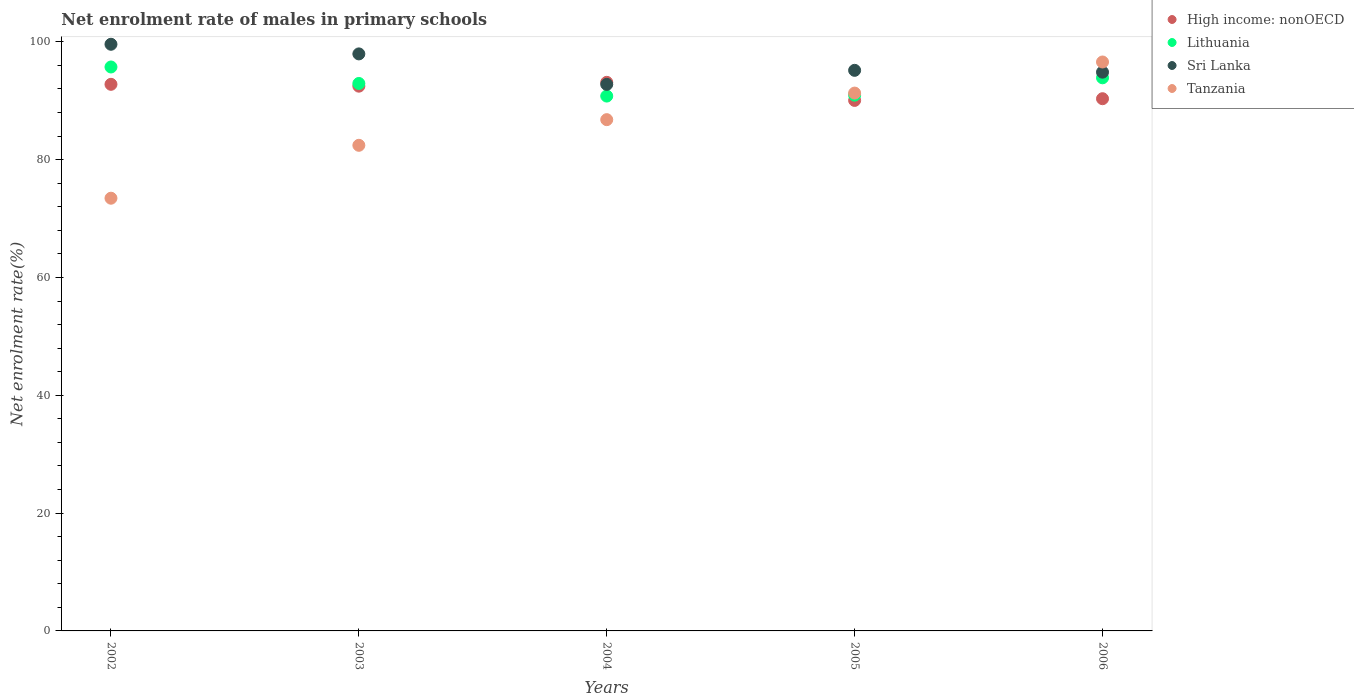How many different coloured dotlines are there?
Give a very brief answer. 4. Is the number of dotlines equal to the number of legend labels?
Provide a succinct answer. Yes. What is the net enrolment rate of males in primary schools in Lithuania in 2005?
Keep it short and to the point. 90.94. Across all years, what is the maximum net enrolment rate of males in primary schools in Lithuania?
Make the answer very short. 95.73. Across all years, what is the minimum net enrolment rate of males in primary schools in Lithuania?
Ensure brevity in your answer.  90.79. In which year was the net enrolment rate of males in primary schools in Sri Lanka minimum?
Offer a terse response. 2004. What is the total net enrolment rate of males in primary schools in High income: nonOECD in the graph?
Your answer should be very brief. 458.77. What is the difference between the net enrolment rate of males in primary schools in Sri Lanka in 2002 and that in 2003?
Provide a succinct answer. 1.63. What is the difference between the net enrolment rate of males in primary schools in Sri Lanka in 2006 and the net enrolment rate of males in primary schools in Lithuania in 2002?
Your answer should be very brief. -0.88. What is the average net enrolment rate of males in primary schools in Sri Lanka per year?
Your response must be concise. 96.06. In the year 2003, what is the difference between the net enrolment rate of males in primary schools in High income: nonOECD and net enrolment rate of males in primary schools in Sri Lanka?
Make the answer very short. -5.48. In how many years, is the net enrolment rate of males in primary schools in Sri Lanka greater than 12 %?
Provide a succinct answer. 5. What is the ratio of the net enrolment rate of males in primary schools in Tanzania in 2003 to that in 2004?
Keep it short and to the point. 0.95. What is the difference between the highest and the second highest net enrolment rate of males in primary schools in Sri Lanka?
Your response must be concise. 1.63. What is the difference between the highest and the lowest net enrolment rate of males in primary schools in Lithuania?
Keep it short and to the point. 4.94. Is the sum of the net enrolment rate of males in primary schools in High income: nonOECD in 2002 and 2003 greater than the maximum net enrolment rate of males in primary schools in Tanzania across all years?
Your response must be concise. Yes. Is it the case that in every year, the sum of the net enrolment rate of males in primary schools in High income: nonOECD and net enrolment rate of males in primary schools in Sri Lanka  is greater than the net enrolment rate of males in primary schools in Tanzania?
Provide a short and direct response. Yes. Is the net enrolment rate of males in primary schools in Sri Lanka strictly greater than the net enrolment rate of males in primary schools in Lithuania over the years?
Your answer should be compact. Yes. How many dotlines are there?
Provide a short and direct response. 4. What is the difference between two consecutive major ticks on the Y-axis?
Give a very brief answer. 20. Are the values on the major ticks of Y-axis written in scientific E-notation?
Offer a terse response. No. Where does the legend appear in the graph?
Your response must be concise. Top right. How many legend labels are there?
Make the answer very short. 4. How are the legend labels stacked?
Give a very brief answer. Vertical. What is the title of the graph?
Keep it short and to the point. Net enrolment rate of males in primary schools. What is the label or title of the Y-axis?
Provide a succinct answer. Net enrolment rate(%). What is the Net enrolment rate(%) of High income: nonOECD in 2002?
Give a very brief answer. 92.78. What is the Net enrolment rate(%) of Lithuania in 2002?
Your answer should be very brief. 95.73. What is the Net enrolment rate(%) of Sri Lanka in 2002?
Keep it short and to the point. 99.58. What is the Net enrolment rate(%) in Tanzania in 2002?
Ensure brevity in your answer.  73.45. What is the Net enrolment rate(%) of High income: nonOECD in 2003?
Keep it short and to the point. 92.47. What is the Net enrolment rate(%) of Lithuania in 2003?
Give a very brief answer. 92.93. What is the Net enrolment rate(%) in Sri Lanka in 2003?
Your answer should be very brief. 97.95. What is the Net enrolment rate(%) of Tanzania in 2003?
Provide a succinct answer. 82.43. What is the Net enrolment rate(%) of High income: nonOECD in 2004?
Make the answer very short. 93.12. What is the Net enrolment rate(%) of Lithuania in 2004?
Ensure brevity in your answer.  90.79. What is the Net enrolment rate(%) of Sri Lanka in 2004?
Ensure brevity in your answer.  92.78. What is the Net enrolment rate(%) in Tanzania in 2004?
Your answer should be compact. 86.79. What is the Net enrolment rate(%) in High income: nonOECD in 2005?
Ensure brevity in your answer.  90.05. What is the Net enrolment rate(%) of Lithuania in 2005?
Make the answer very short. 90.94. What is the Net enrolment rate(%) in Sri Lanka in 2005?
Offer a very short reply. 95.16. What is the Net enrolment rate(%) of Tanzania in 2005?
Your answer should be compact. 91.3. What is the Net enrolment rate(%) in High income: nonOECD in 2006?
Your answer should be compact. 90.34. What is the Net enrolment rate(%) of Lithuania in 2006?
Ensure brevity in your answer.  93.89. What is the Net enrolment rate(%) in Sri Lanka in 2006?
Make the answer very short. 94.85. What is the Net enrolment rate(%) in Tanzania in 2006?
Ensure brevity in your answer.  96.57. Across all years, what is the maximum Net enrolment rate(%) of High income: nonOECD?
Your response must be concise. 93.12. Across all years, what is the maximum Net enrolment rate(%) in Lithuania?
Your answer should be compact. 95.73. Across all years, what is the maximum Net enrolment rate(%) of Sri Lanka?
Provide a short and direct response. 99.58. Across all years, what is the maximum Net enrolment rate(%) of Tanzania?
Your answer should be compact. 96.57. Across all years, what is the minimum Net enrolment rate(%) of High income: nonOECD?
Your answer should be compact. 90.05. Across all years, what is the minimum Net enrolment rate(%) in Lithuania?
Your answer should be very brief. 90.79. Across all years, what is the minimum Net enrolment rate(%) of Sri Lanka?
Ensure brevity in your answer.  92.78. Across all years, what is the minimum Net enrolment rate(%) of Tanzania?
Give a very brief answer. 73.45. What is the total Net enrolment rate(%) in High income: nonOECD in the graph?
Make the answer very short. 458.77. What is the total Net enrolment rate(%) in Lithuania in the graph?
Ensure brevity in your answer.  464.28. What is the total Net enrolment rate(%) of Sri Lanka in the graph?
Ensure brevity in your answer.  480.31. What is the total Net enrolment rate(%) in Tanzania in the graph?
Provide a succinct answer. 430.55. What is the difference between the Net enrolment rate(%) of High income: nonOECD in 2002 and that in 2003?
Give a very brief answer. 0.31. What is the difference between the Net enrolment rate(%) of Lithuania in 2002 and that in 2003?
Your answer should be compact. 2.8. What is the difference between the Net enrolment rate(%) in Sri Lanka in 2002 and that in 2003?
Make the answer very short. 1.63. What is the difference between the Net enrolment rate(%) in Tanzania in 2002 and that in 2003?
Provide a short and direct response. -8.98. What is the difference between the Net enrolment rate(%) of High income: nonOECD in 2002 and that in 2004?
Your answer should be very brief. -0.34. What is the difference between the Net enrolment rate(%) of Lithuania in 2002 and that in 2004?
Provide a succinct answer. 4.94. What is the difference between the Net enrolment rate(%) in Sri Lanka in 2002 and that in 2004?
Provide a succinct answer. 6.81. What is the difference between the Net enrolment rate(%) in Tanzania in 2002 and that in 2004?
Make the answer very short. -13.33. What is the difference between the Net enrolment rate(%) of High income: nonOECD in 2002 and that in 2005?
Offer a very short reply. 2.73. What is the difference between the Net enrolment rate(%) of Lithuania in 2002 and that in 2005?
Your answer should be compact. 4.78. What is the difference between the Net enrolment rate(%) of Sri Lanka in 2002 and that in 2005?
Provide a succinct answer. 4.43. What is the difference between the Net enrolment rate(%) in Tanzania in 2002 and that in 2005?
Ensure brevity in your answer.  -17.85. What is the difference between the Net enrolment rate(%) of High income: nonOECD in 2002 and that in 2006?
Your answer should be very brief. 2.44. What is the difference between the Net enrolment rate(%) of Lithuania in 2002 and that in 2006?
Provide a succinct answer. 1.84. What is the difference between the Net enrolment rate(%) in Sri Lanka in 2002 and that in 2006?
Keep it short and to the point. 4.74. What is the difference between the Net enrolment rate(%) in Tanzania in 2002 and that in 2006?
Provide a short and direct response. -23.12. What is the difference between the Net enrolment rate(%) in High income: nonOECD in 2003 and that in 2004?
Offer a terse response. -0.65. What is the difference between the Net enrolment rate(%) of Lithuania in 2003 and that in 2004?
Offer a very short reply. 2.14. What is the difference between the Net enrolment rate(%) in Sri Lanka in 2003 and that in 2004?
Offer a very short reply. 5.17. What is the difference between the Net enrolment rate(%) in Tanzania in 2003 and that in 2004?
Keep it short and to the point. -4.35. What is the difference between the Net enrolment rate(%) of High income: nonOECD in 2003 and that in 2005?
Your answer should be very brief. 2.42. What is the difference between the Net enrolment rate(%) of Lithuania in 2003 and that in 2005?
Offer a very short reply. 1.99. What is the difference between the Net enrolment rate(%) of Sri Lanka in 2003 and that in 2005?
Offer a terse response. 2.79. What is the difference between the Net enrolment rate(%) in Tanzania in 2003 and that in 2005?
Give a very brief answer. -8.87. What is the difference between the Net enrolment rate(%) of High income: nonOECD in 2003 and that in 2006?
Offer a terse response. 2.13. What is the difference between the Net enrolment rate(%) in Lithuania in 2003 and that in 2006?
Give a very brief answer. -0.96. What is the difference between the Net enrolment rate(%) in Sri Lanka in 2003 and that in 2006?
Your answer should be compact. 3.1. What is the difference between the Net enrolment rate(%) of Tanzania in 2003 and that in 2006?
Provide a succinct answer. -14.14. What is the difference between the Net enrolment rate(%) of High income: nonOECD in 2004 and that in 2005?
Your answer should be compact. 3.07. What is the difference between the Net enrolment rate(%) of Lithuania in 2004 and that in 2005?
Offer a terse response. -0.15. What is the difference between the Net enrolment rate(%) of Sri Lanka in 2004 and that in 2005?
Give a very brief answer. -2.38. What is the difference between the Net enrolment rate(%) in Tanzania in 2004 and that in 2005?
Your answer should be very brief. -4.51. What is the difference between the Net enrolment rate(%) in High income: nonOECD in 2004 and that in 2006?
Provide a short and direct response. 2.78. What is the difference between the Net enrolment rate(%) of Lithuania in 2004 and that in 2006?
Provide a succinct answer. -3.1. What is the difference between the Net enrolment rate(%) of Sri Lanka in 2004 and that in 2006?
Your response must be concise. -2.07. What is the difference between the Net enrolment rate(%) in Tanzania in 2004 and that in 2006?
Provide a succinct answer. -9.79. What is the difference between the Net enrolment rate(%) of High income: nonOECD in 2005 and that in 2006?
Your answer should be compact. -0.29. What is the difference between the Net enrolment rate(%) of Lithuania in 2005 and that in 2006?
Make the answer very short. -2.95. What is the difference between the Net enrolment rate(%) of Sri Lanka in 2005 and that in 2006?
Ensure brevity in your answer.  0.31. What is the difference between the Net enrolment rate(%) of Tanzania in 2005 and that in 2006?
Your answer should be very brief. -5.28. What is the difference between the Net enrolment rate(%) of High income: nonOECD in 2002 and the Net enrolment rate(%) of Lithuania in 2003?
Your answer should be very brief. -0.15. What is the difference between the Net enrolment rate(%) of High income: nonOECD in 2002 and the Net enrolment rate(%) of Sri Lanka in 2003?
Offer a terse response. -5.16. What is the difference between the Net enrolment rate(%) in High income: nonOECD in 2002 and the Net enrolment rate(%) in Tanzania in 2003?
Offer a terse response. 10.35. What is the difference between the Net enrolment rate(%) of Lithuania in 2002 and the Net enrolment rate(%) of Sri Lanka in 2003?
Make the answer very short. -2.22. What is the difference between the Net enrolment rate(%) of Lithuania in 2002 and the Net enrolment rate(%) of Tanzania in 2003?
Your response must be concise. 13.3. What is the difference between the Net enrolment rate(%) in Sri Lanka in 2002 and the Net enrolment rate(%) in Tanzania in 2003?
Your answer should be compact. 17.15. What is the difference between the Net enrolment rate(%) in High income: nonOECD in 2002 and the Net enrolment rate(%) in Lithuania in 2004?
Provide a succinct answer. 1.99. What is the difference between the Net enrolment rate(%) of High income: nonOECD in 2002 and the Net enrolment rate(%) of Sri Lanka in 2004?
Provide a succinct answer. 0.01. What is the difference between the Net enrolment rate(%) in High income: nonOECD in 2002 and the Net enrolment rate(%) in Tanzania in 2004?
Give a very brief answer. 6. What is the difference between the Net enrolment rate(%) of Lithuania in 2002 and the Net enrolment rate(%) of Sri Lanka in 2004?
Offer a terse response. 2.95. What is the difference between the Net enrolment rate(%) in Lithuania in 2002 and the Net enrolment rate(%) in Tanzania in 2004?
Provide a succinct answer. 8.94. What is the difference between the Net enrolment rate(%) of Sri Lanka in 2002 and the Net enrolment rate(%) of Tanzania in 2004?
Your response must be concise. 12.8. What is the difference between the Net enrolment rate(%) of High income: nonOECD in 2002 and the Net enrolment rate(%) of Lithuania in 2005?
Provide a short and direct response. 1.84. What is the difference between the Net enrolment rate(%) in High income: nonOECD in 2002 and the Net enrolment rate(%) in Sri Lanka in 2005?
Keep it short and to the point. -2.37. What is the difference between the Net enrolment rate(%) of High income: nonOECD in 2002 and the Net enrolment rate(%) of Tanzania in 2005?
Give a very brief answer. 1.49. What is the difference between the Net enrolment rate(%) in Lithuania in 2002 and the Net enrolment rate(%) in Sri Lanka in 2005?
Your answer should be compact. 0.57. What is the difference between the Net enrolment rate(%) in Lithuania in 2002 and the Net enrolment rate(%) in Tanzania in 2005?
Offer a terse response. 4.43. What is the difference between the Net enrolment rate(%) of Sri Lanka in 2002 and the Net enrolment rate(%) of Tanzania in 2005?
Your response must be concise. 8.29. What is the difference between the Net enrolment rate(%) of High income: nonOECD in 2002 and the Net enrolment rate(%) of Lithuania in 2006?
Give a very brief answer. -1.11. What is the difference between the Net enrolment rate(%) in High income: nonOECD in 2002 and the Net enrolment rate(%) in Sri Lanka in 2006?
Make the answer very short. -2.06. What is the difference between the Net enrolment rate(%) of High income: nonOECD in 2002 and the Net enrolment rate(%) of Tanzania in 2006?
Provide a succinct answer. -3.79. What is the difference between the Net enrolment rate(%) of Lithuania in 2002 and the Net enrolment rate(%) of Sri Lanka in 2006?
Keep it short and to the point. 0.88. What is the difference between the Net enrolment rate(%) of Lithuania in 2002 and the Net enrolment rate(%) of Tanzania in 2006?
Your answer should be very brief. -0.85. What is the difference between the Net enrolment rate(%) of Sri Lanka in 2002 and the Net enrolment rate(%) of Tanzania in 2006?
Offer a very short reply. 3.01. What is the difference between the Net enrolment rate(%) of High income: nonOECD in 2003 and the Net enrolment rate(%) of Lithuania in 2004?
Provide a short and direct response. 1.68. What is the difference between the Net enrolment rate(%) of High income: nonOECD in 2003 and the Net enrolment rate(%) of Sri Lanka in 2004?
Keep it short and to the point. -0.3. What is the difference between the Net enrolment rate(%) in High income: nonOECD in 2003 and the Net enrolment rate(%) in Tanzania in 2004?
Provide a short and direct response. 5.68. What is the difference between the Net enrolment rate(%) of Lithuania in 2003 and the Net enrolment rate(%) of Sri Lanka in 2004?
Offer a terse response. 0.15. What is the difference between the Net enrolment rate(%) of Lithuania in 2003 and the Net enrolment rate(%) of Tanzania in 2004?
Provide a short and direct response. 6.14. What is the difference between the Net enrolment rate(%) of Sri Lanka in 2003 and the Net enrolment rate(%) of Tanzania in 2004?
Provide a succinct answer. 11.16. What is the difference between the Net enrolment rate(%) in High income: nonOECD in 2003 and the Net enrolment rate(%) in Lithuania in 2005?
Offer a terse response. 1.53. What is the difference between the Net enrolment rate(%) in High income: nonOECD in 2003 and the Net enrolment rate(%) in Sri Lanka in 2005?
Your answer should be very brief. -2.69. What is the difference between the Net enrolment rate(%) in High income: nonOECD in 2003 and the Net enrolment rate(%) in Tanzania in 2005?
Provide a short and direct response. 1.17. What is the difference between the Net enrolment rate(%) of Lithuania in 2003 and the Net enrolment rate(%) of Sri Lanka in 2005?
Keep it short and to the point. -2.23. What is the difference between the Net enrolment rate(%) in Lithuania in 2003 and the Net enrolment rate(%) in Tanzania in 2005?
Offer a very short reply. 1.63. What is the difference between the Net enrolment rate(%) in Sri Lanka in 2003 and the Net enrolment rate(%) in Tanzania in 2005?
Provide a succinct answer. 6.65. What is the difference between the Net enrolment rate(%) in High income: nonOECD in 2003 and the Net enrolment rate(%) in Lithuania in 2006?
Keep it short and to the point. -1.42. What is the difference between the Net enrolment rate(%) of High income: nonOECD in 2003 and the Net enrolment rate(%) of Sri Lanka in 2006?
Keep it short and to the point. -2.38. What is the difference between the Net enrolment rate(%) of High income: nonOECD in 2003 and the Net enrolment rate(%) of Tanzania in 2006?
Your response must be concise. -4.1. What is the difference between the Net enrolment rate(%) in Lithuania in 2003 and the Net enrolment rate(%) in Sri Lanka in 2006?
Your answer should be compact. -1.92. What is the difference between the Net enrolment rate(%) of Lithuania in 2003 and the Net enrolment rate(%) of Tanzania in 2006?
Give a very brief answer. -3.64. What is the difference between the Net enrolment rate(%) in Sri Lanka in 2003 and the Net enrolment rate(%) in Tanzania in 2006?
Provide a short and direct response. 1.37. What is the difference between the Net enrolment rate(%) of High income: nonOECD in 2004 and the Net enrolment rate(%) of Lithuania in 2005?
Offer a terse response. 2.18. What is the difference between the Net enrolment rate(%) in High income: nonOECD in 2004 and the Net enrolment rate(%) in Sri Lanka in 2005?
Provide a short and direct response. -2.04. What is the difference between the Net enrolment rate(%) of High income: nonOECD in 2004 and the Net enrolment rate(%) of Tanzania in 2005?
Provide a succinct answer. 1.82. What is the difference between the Net enrolment rate(%) of Lithuania in 2004 and the Net enrolment rate(%) of Sri Lanka in 2005?
Ensure brevity in your answer.  -4.37. What is the difference between the Net enrolment rate(%) of Lithuania in 2004 and the Net enrolment rate(%) of Tanzania in 2005?
Ensure brevity in your answer.  -0.51. What is the difference between the Net enrolment rate(%) of Sri Lanka in 2004 and the Net enrolment rate(%) of Tanzania in 2005?
Keep it short and to the point. 1.48. What is the difference between the Net enrolment rate(%) in High income: nonOECD in 2004 and the Net enrolment rate(%) in Lithuania in 2006?
Offer a terse response. -0.77. What is the difference between the Net enrolment rate(%) of High income: nonOECD in 2004 and the Net enrolment rate(%) of Sri Lanka in 2006?
Offer a very short reply. -1.72. What is the difference between the Net enrolment rate(%) of High income: nonOECD in 2004 and the Net enrolment rate(%) of Tanzania in 2006?
Your response must be concise. -3.45. What is the difference between the Net enrolment rate(%) of Lithuania in 2004 and the Net enrolment rate(%) of Sri Lanka in 2006?
Your answer should be compact. -4.06. What is the difference between the Net enrolment rate(%) in Lithuania in 2004 and the Net enrolment rate(%) in Tanzania in 2006?
Keep it short and to the point. -5.78. What is the difference between the Net enrolment rate(%) of Sri Lanka in 2004 and the Net enrolment rate(%) of Tanzania in 2006?
Make the answer very short. -3.8. What is the difference between the Net enrolment rate(%) in High income: nonOECD in 2005 and the Net enrolment rate(%) in Lithuania in 2006?
Offer a very short reply. -3.84. What is the difference between the Net enrolment rate(%) of High income: nonOECD in 2005 and the Net enrolment rate(%) of Sri Lanka in 2006?
Your answer should be compact. -4.8. What is the difference between the Net enrolment rate(%) in High income: nonOECD in 2005 and the Net enrolment rate(%) in Tanzania in 2006?
Your answer should be very brief. -6.52. What is the difference between the Net enrolment rate(%) in Lithuania in 2005 and the Net enrolment rate(%) in Sri Lanka in 2006?
Your answer should be very brief. -3.9. What is the difference between the Net enrolment rate(%) of Lithuania in 2005 and the Net enrolment rate(%) of Tanzania in 2006?
Provide a short and direct response. -5.63. What is the difference between the Net enrolment rate(%) of Sri Lanka in 2005 and the Net enrolment rate(%) of Tanzania in 2006?
Give a very brief answer. -1.42. What is the average Net enrolment rate(%) of High income: nonOECD per year?
Your answer should be very brief. 91.75. What is the average Net enrolment rate(%) of Lithuania per year?
Offer a terse response. 92.86. What is the average Net enrolment rate(%) of Sri Lanka per year?
Keep it short and to the point. 96.06. What is the average Net enrolment rate(%) of Tanzania per year?
Make the answer very short. 86.11. In the year 2002, what is the difference between the Net enrolment rate(%) in High income: nonOECD and Net enrolment rate(%) in Lithuania?
Give a very brief answer. -2.94. In the year 2002, what is the difference between the Net enrolment rate(%) in High income: nonOECD and Net enrolment rate(%) in Sri Lanka?
Provide a short and direct response. -6.8. In the year 2002, what is the difference between the Net enrolment rate(%) of High income: nonOECD and Net enrolment rate(%) of Tanzania?
Provide a succinct answer. 19.33. In the year 2002, what is the difference between the Net enrolment rate(%) in Lithuania and Net enrolment rate(%) in Sri Lanka?
Keep it short and to the point. -3.86. In the year 2002, what is the difference between the Net enrolment rate(%) in Lithuania and Net enrolment rate(%) in Tanzania?
Your answer should be very brief. 22.28. In the year 2002, what is the difference between the Net enrolment rate(%) of Sri Lanka and Net enrolment rate(%) of Tanzania?
Your response must be concise. 26.13. In the year 2003, what is the difference between the Net enrolment rate(%) in High income: nonOECD and Net enrolment rate(%) in Lithuania?
Ensure brevity in your answer.  -0.46. In the year 2003, what is the difference between the Net enrolment rate(%) in High income: nonOECD and Net enrolment rate(%) in Sri Lanka?
Make the answer very short. -5.48. In the year 2003, what is the difference between the Net enrolment rate(%) of High income: nonOECD and Net enrolment rate(%) of Tanzania?
Make the answer very short. 10.04. In the year 2003, what is the difference between the Net enrolment rate(%) of Lithuania and Net enrolment rate(%) of Sri Lanka?
Give a very brief answer. -5.02. In the year 2003, what is the difference between the Net enrolment rate(%) of Lithuania and Net enrolment rate(%) of Tanzania?
Your answer should be compact. 10.5. In the year 2003, what is the difference between the Net enrolment rate(%) in Sri Lanka and Net enrolment rate(%) in Tanzania?
Ensure brevity in your answer.  15.52. In the year 2004, what is the difference between the Net enrolment rate(%) in High income: nonOECD and Net enrolment rate(%) in Lithuania?
Offer a very short reply. 2.33. In the year 2004, what is the difference between the Net enrolment rate(%) in High income: nonOECD and Net enrolment rate(%) in Sri Lanka?
Provide a short and direct response. 0.35. In the year 2004, what is the difference between the Net enrolment rate(%) of High income: nonOECD and Net enrolment rate(%) of Tanzania?
Your answer should be very brief. 6.34. In the year 2004, what is the difference between the Net enrolment rate(%) of Lithuania and Net enrolment rate(%) of Sri Lanka?
Provide a succinct answer. -1.98. In the year 2004, what is the difference between the Net enrolment rate(%) in Lithuania and Net enrolment rate(%) in Tanzania?
Make the answer very short. 4. In the year 2004, what is the difference between the Net enrolment rate(%) of Sri Lanka and Net enrolment rate(%) of Tanzania?
Your answer should be very brief. 5.99. In the year 2005, what is the difference between the Net enrolment rate(%) in High income: nonOECD and Net enrolment rate(%) in Lithuania?
Your answer should be compact. -0.89. In the year 2005, what is the difference between the Net enrolment rate(%) in High income: nonOECD and Net enrolment rate(%) in Sri Lanka?
Provide a short and direct response. -5.11. In the year 2005, what is the difference between the Net enrolment rate(%) in High income: nonOECD and Net enrolment rate(%) in Tanzania?
Give a very brief answer. -1.25. In the year 2005, what is the difference between the Net enrolment rate(%) in Lithuania and Net enrolment rate(%) in Sri Lanka?
Offer a very short reply. -4.21. In the year 2005, what is the difference between the Net enrolment rate(%) of Lithuania and Net enrolment rate(%) of Tanzania?
Ensure brevity in your answer.  -0.35. In the year 2005, what is the difference between the Net enrolment rate(%) in Sri Lanka and Net enrolment rate(%) in Tanzania?
Provide a succinct answer. 3.86. In the year 2006, what is the difference between the Net enrolment rate(%) in High income: nonOECD and Net enrolment rate(%) in Lithuania?
Provide a succinct answer. -3.55. In the year 2006, what is the difference between the Net enrolment rate(%) in High income: nonOECD and Net enrolment rate(%) in Sri Lanka?
Offer a very short reply. -4.51. In the year 2006, what is the difference between the Net enrolment rate(%) in High income: nonOECD and Net enrolment rate(%) in Tanzania?
Ensure brevity in your answer.  -6.23. In the year 2006, what is the difference between the Net enrolment rate(%) of Lithuania and Net enrolment rate(%) of Sri Lanka?
Provide a short and direct response. -0.96. In the year 2006, what is the difference between the Net enrolment rate(%) of Lithuania and Net enrolment rate(%) of Tanzania?
Offer a very short reply. -2.68. In the year 2006, what is the difference between the Net enrolment rate(%) of Sri Lanka and Net enrolment rate(%) of Tanzania?
Your answer should be compact. -1.73. What is the ratio of the Net enrolment rate(%) of High income: nonOECD in 2002 to that in 2003?
Offer a terse response. 1. What is the ratio of the Net enrolment rate(%) of Lithuania in 2002 to that in 2003?
Your response must be concise. 1.03. What is the ratio of the Net enrolment rate(%) in Sri Lanka in 2002 to that in 2003?
Keep it short and to the point. 1.02. What is the ratio of the Net enrolment rate(%) of Tanzania in 2002 to that in 2003?
Ensure brevity in your answer.  0.89. What is the ratio of the Net enrolment rate(%) in High income: nonOECD in 2002 to that in 2004?
Provide a short and direct response. 1. What is the ratio of the Net enrolment rate(%) of Lithuania in 2002 to that in 2004?
Offer a very short reply. 1.05. What is the ratio of the Net enrolment rate(%) in Sri Lanka in 2002 to that in 2004?
Provide a short and direct response. 1.07. What is the ratio of the Net enrolment rate(%) in Tanzania in 2002 to that in 2004?
Offer a terse response. 0.85. What is the ratio of the Net enrolment rate(%) in High income: nonOECD in 2002 to that in 2005?
Provide a succinct answer. 1.03. What is the ratio of the Net enrolment rate(%) of Lithuania in 2002 to that in 2005?
Offer a very short reply. 1.05. What is the ratio of the Net enrolment rate(%) in Sri Lanka in 2002 to that in 2005?
Give a very brief answer. 1.05. What is the ratio of the Net enrolment rate(%) in Tanzania in 2002 to that in 2005?
Keep it short and to the point. 0.8. What is the ratio of the Net enrolment rate(%) in Lithuania in 2002 to that in 2006?
Your answer should be very brief. 1.02. What is the ratio of the Net enrolment rate(%) of Sri Lanka in 2002 to that in 2006?
Provide a succinct answer. 1.05. What is the ratio of the Net enrolment rate(%) in Tanzania in 2002 to that in 2006?
Offer a terse response. 0.76. What is the ratio of the Net enrolment rate(%) of Lithuania in 2003 to that in 2004?
Offer a terse response. 1.02. What is the ratio of the Net enrolment rate(%) in Sri Lanka in 2003 to that in 2004?
Your answer should be compact. 1.06. What is the ratio of the Net enrolment rate(%) in Tanzania in 2003 to that in 2004?
Your answer should be compact. 0.95. What is the ratio of the Net enrolment rate(%) in High income: nonOECD in 2003 to that in 2005?
Ensure brevity in your answer.  1.03. What is the ratio of the Net enrolment rate(%) of Lithuania in 2003 to that in 2005?
Give a very brief answer. 1.02. What is the ratio of the Net enrolment rate(%) in Sri Lanka in 2003 to that in 2005?
Offer a very short reply. 1.03. What is the ratio of the Net enrolment rate(%) of Tanzania in 2003 to that in 2005?
Provide a short and direct response. 0.9. What is the ratio of the Net enrolment rate(%) of High income: nonOECD in 2003 to that in 2006?
Ensure brevity in your answer.  1.02. What is the ratio of the Net enrolment rate(%) of Sri Lanka in 2003 to that in 2006?
Your response must be concise. 1.03. What is the ratio of the Net enrolment rate(%) of Tanzania in 2003 to that in 2006?
Provide a short and direct response. 0.85. What is the ratio of the Net enrolment rate(%) in High income: nonOECD in 2004 to that in 2005?
Your response must be concise. 1.03. What is the ratio of the Net enrolment rate(%) in Sri Lanka in 2004 to that in 2005?
Provide a short and direct response. 0.97. What is the ratio of the Net enrolment rate(%) of Tanzania in 2004 to that in 2005?
Your answer should be compact. 0.95. What is the ratio of the Net enrolment rate(%) of High income: nonOECD in 2004 to that in 2006?
Offer a very short reply. 1.03. What is the ratio of the Net enrolment rate(%) of Lithuania in 2004 to that in 2006?
Offer a terse response. 0.97. What is the ratio of the Net enrolment rate(%) in Sri Lanka in 2004 to that in 2006?
Your answer should be compact. 0.98. What is the ratio of the Net enrolment rate(%) in Tanzania in 2004 to that in 2006?
Ensure brevity in your answer.  0.9. What is the ratio of the Net enrolment rate(%) of High income: nonOECD in 2005 to that in 2006?
Provide a short and direct response. 1. What is the ratio of the Net enrolment rate(%) of Lithuania in 2005 to that in 2006?
Your response must be concise. 0.97. What is the ratio of the Net enrolment rate(%) in Tanzania in 2005 to that in 2006?
Give a very brief answer. 0.95. What is the difference between the highest and the second highest Net enrolment rate(%) of High income: nonOECD?
Provide a short and direct response. 0.34. What is the difference between the highest and the second highest Net enrolment rate(%) of Lithuania?
Your answer should be very brief. 1.84. What is the difference between the highest and the second highest Net enrolment rate(%) of Sri Lanka?
Make the answer very short. 1.63. What is the difference between the highest and the second highest Net enrolment rate(%) of Tanzania?
Provide a succinct answer. 5.28. What is the difference between the highest and the lowest Net enrolment rate(%) in High income: nonOECD?
Your response must be concise. 3.07. What is the difference between the highest and the lowest Net enrolment rate(%) in Lithuania?
Offer a terse response. 4.94. What is the difference between the highest and the lowest Net enrolment rate(%) of Sri Lanka?
Offer a terse response. 6.81. What is the difference between the highest and the lowest Net enrolment rate(%) of Tanzania?
Make the answer very short. 23.12. 